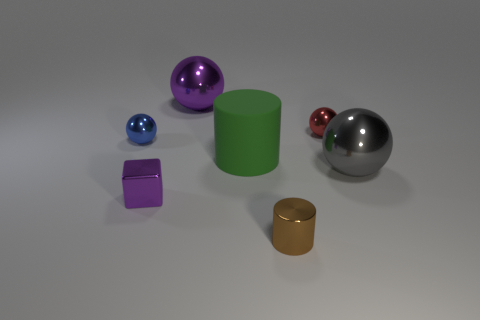There is a brown shiny thing; is it the same shape as the purple thing that is in front of the large gray sphere?
Keep it short and to the point. No. Are there fewer brown shiny objects that are on the left side of the brown shiny thing than large gray metallic things?
Make the answer very short. Yes. There is a tiny red sphere; are there any large purple metallic things in front of it?
Keep it short and to the point. No. Are there any tiny objects of the same shape as the big green object?
Offer a very short reply. Yes. What is the shape of the purple metal object that is the same size as the green thing?
Provide a short and direct response. Sphere. How many objects are either small metal balls on the left side of the red sphere or red metal balls?
Your answer should be very brief. 2. Does the large rubber cylinder have the same color as the small cylinder?
Offer a very short reply. No. There is a shiny thing in front of the metallic cube; how big is it?
Make the answer very short. Small. Are there any brown things that have the same size as the brown cylinder?
Give a very brief answer. No. There is a purple metallic object that is in front of the gray shiny ball; is its size the same as the red object?
Offer a terse response. Yes. 